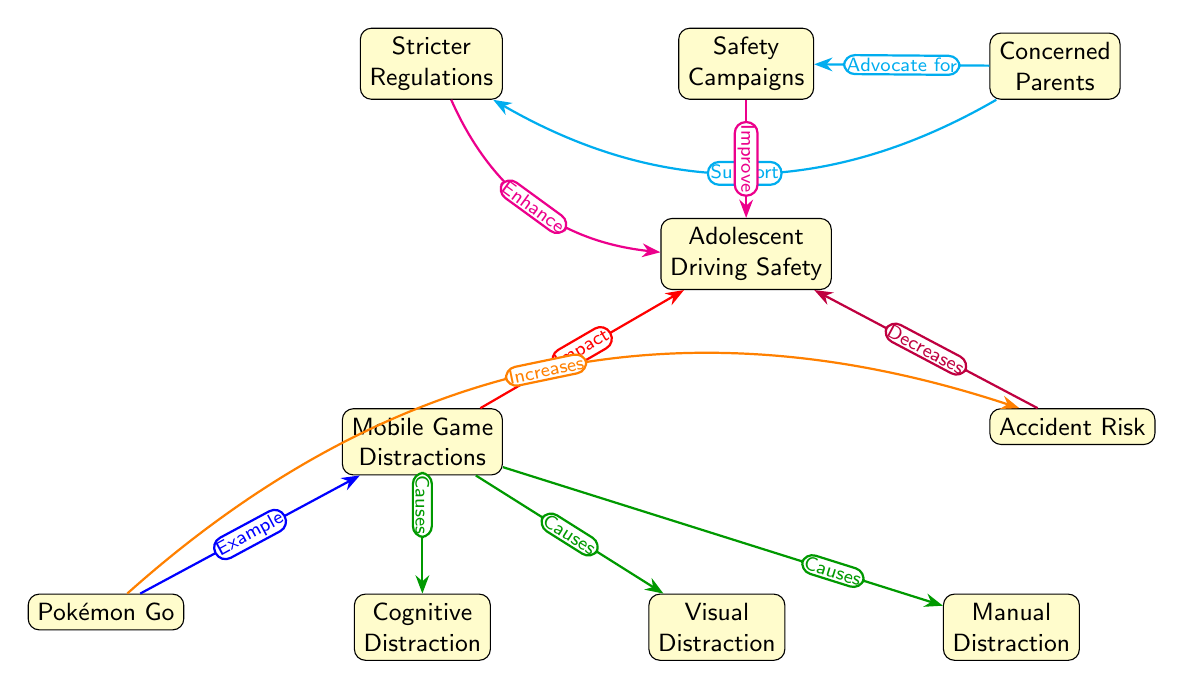What is the main focus of the diagram? The main focus of the diagram is centered around "Adolescent Driving Safety," which is indicated as the central node in the diagram, showing that it is the primary subject being analyzed.
Answer: Adolescent Driving Safety How many nodes are there in total? Counting all the nodes visualized in the diagram, including the main node and its connected nodes, there are a total of 10 nodes that represent various factors related to adolescent driving and distractions.
Answer: 10 Which node represents a specific mobile game? The node "Pokémon Go" explicitly identifies a well-known mobile game and serves as an example of mobile game distractions, connected to the "Mobile Game Distractions" node.
Answer: Pokémon Go What type of distraction does "Mobile Game Distractions" cause? "Mobile Game Distractions" leads to multiple types of distractions, including "Cognitive Distraction," "Visual Distraction," and "Manual Distraction," which are depicted in the diagram as consequences of the mobile game distractions.
Answer: Cognitive, Visual, Manual Who advocates for safety campaigns according to the diagram? The node "Concerned Parents" indicates that parents are proactive advocates for safety campaigns, aiming to promote better driving safety among adolescents as shown by the connection in the diagram.
Answer: Concerned Parents What is the relationship between "Accident Risk" and "Adolescent Driving Safety"? The relationship shown in the diagram suggests that an increase in "Accident Risk" leads to a decrease in "Adolescent Driving Safety," which indicates a negative correlation between these two nodes.
Answer: Decreases How do safety campaigns impact adolescent driving safety? The diagram shows that "Safety Campaigns" aim to "Improve" "Adolescent Driving Safety," suggesting that these campaigns have a positive effect on the overall safety of adolescent drivers.
Answer: Improve What do "Stricter Regulations" aim to enhance? "Stricter Regulations" are depicted in the diagram as aiming to enhance "Adolescent Driving Safety," which indicates a goal to implement rules that lead to safer driving practices for adolescents.
Answer: Enhance What does "Pokémon Go" notably increase according to the diagram? The diagram indicates that "Pokémon Go" notably increases "Accident Risk," which suggests that playing this game while driving contributes to a higher likelihood of accidents occurring.
Answer: Increases 